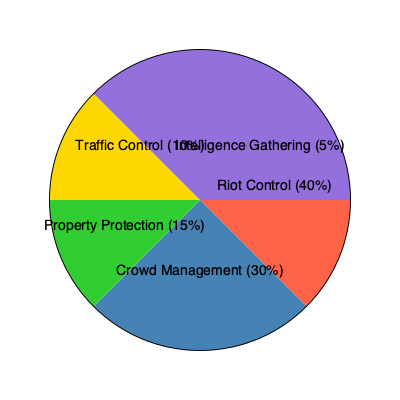According to the pie chart, which two areas of law enforcement resource allocation during civil unrest account for 70% of the total distribution? To answer this question, we need to analyze the pie chart and identify the two largest segments that, when combined, equal 70% of the total distribution. Let's break it down step-by-step:

1. Examine all segments of the pie chart:
   - Riot Control: 40%
   - Crowd Management: 30%
   - Property Protection: 15%
   - Traffic Control: 10%
   - Intelligence Gathering: 5%

2. Identify the two largest segments:
   - Riot Control (40%)
   - Crowd Management (30%)

3. Calculate the sum of these two segments:
   $40\% + 30\% = 70\%$

4. Verify that no other combination of two segments equals 70%:
   - No other combination of two segments adds up to 70%

5. Conclude that Riot Control and Crowd Management are the two areas that account for 70% of the total distribution.

This distribution aligns with a conservative approach to managing civil unrest, prioritizing maintaining order and controlling potentially disruptive situations.
Answer: Riot Control and Crowd Management 